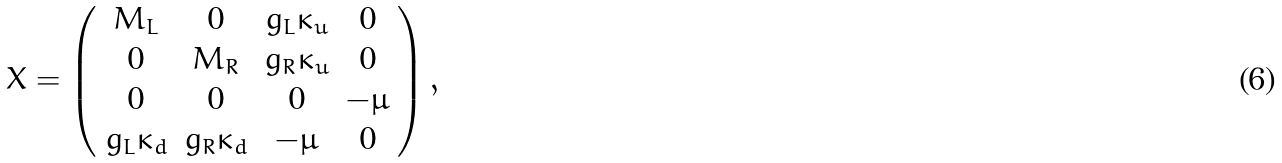Convert formula to latex. <formula><loc_0><loc_0><loc_500><loc_500>X = \left ( \begin{array} { c c c c } M _ { L } & 0 & g _ { L } \kappa _ { u } & 0 \\ 0 & M _ { R } & g _ { R } \kappa _ { u } & 0 \\ 0 & 0 & 0 & - \mu \\ g _ { L } \kappa _ { d } & g _ { R } \kappa _ { d } & - \mu & 0 \end{array} \right ) ,</formula> 